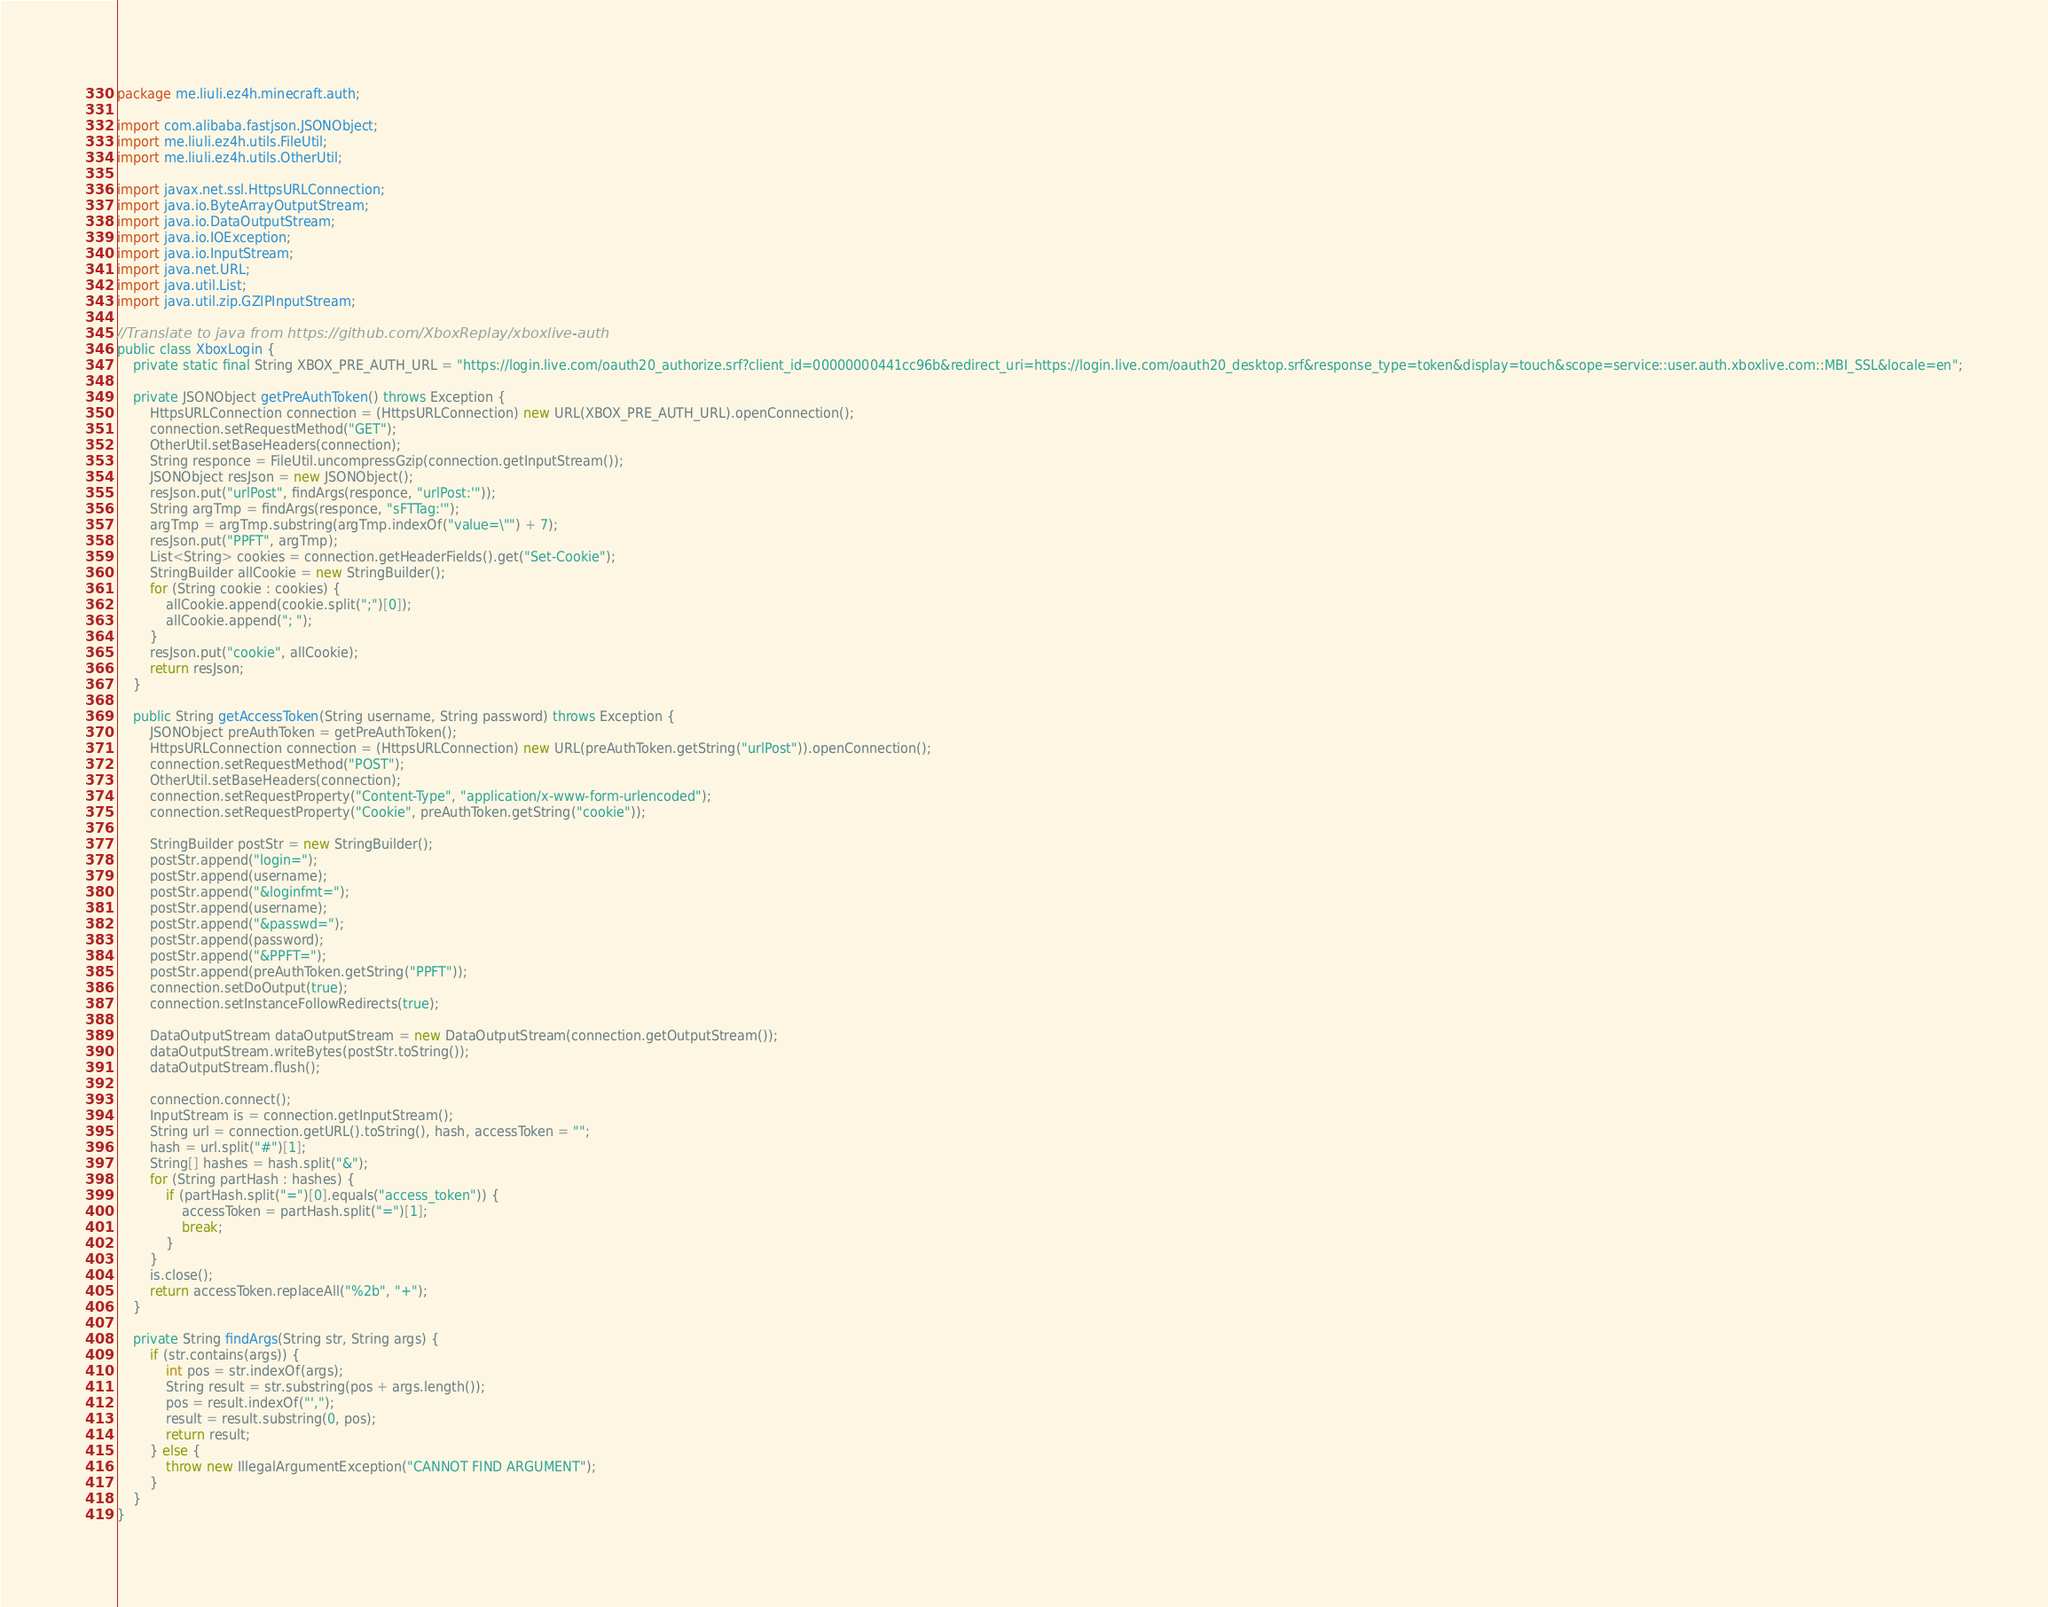<code> <loc_0><loc_0><loc_500><loc_500><_Java_>package me.liuli.ez4h.minecraft.auth;

import com.alibaba.fastjson.JSONObject;
import me.liuli.ez4h.utils.FileUtil;
import me.liuli.ez4h.utils.OtherUtil;

import javax.net.ssl.HttpsURLConnection;
import java.io.ByteArrayOutputStream;
import java.io.DataOutputStream;
import java.io.IOException;
import java.io.InputStream;
import java.net.URL;
import java.util.List;
import java.util.zip.GZIPInputStream;

//Translate to java from https://github.com/XboxReplay/xboxlive-auth
public class XboxLogin {
    private static final String XBOX_PRE_AUTH_URL = "https://login.live.com/oauth20_authorize.srf?client_id=00000000441cc96b&redirect_uri=https://login.live.com/oauth20_desktop.srf&response_type=token&display=touch&scope=service::user.auth.xboxlive.com::MBI_SSL&locale=en";

    private JSONObject getPreAuthToken() throws Exception {
        HttpsURLConnection connection = (HttpsURLConnection) new URL(XBOX_PRE_AUTH_URL).openConnection();
        connection.setRequestMethod("GET");
        OtherUtil.setBaseHeaders(connection);
        String responce = FileUtil.uncompressGzip(connection.getInputStream());
        JSONObject resJson = new JSONObject();
        resJson.put("urlPost", findArgs(responce, "urlPost:'"));
        String argTmp = findArgs(responce, "sFTTag:'");
        argTmp = argTmp.substring(argTmp.indexOf("value=\"") + 7);
        resJson.put("PPFT", argTmp);
        List<String> cookies = connection.getHeaderFields().get("Set-Cookie");
        StringBuilder allCookie = new StringBuilder();
        for (String cookie : cookies) {
            allCookie.append(cookie.split(";")[0]);
            allCookie.append("; ");
        }
        resJson.put("cookie", allCookie);
        return resJson;
    }

    public String getAccessToken(String username, String password) throws Exception {
        JSONObject preAuthToken = getPreAuthToken();
        HttpsURLConnection connection = (HttpsURLConnection) new URL(preAuthToken.getString("urlPost")).openConnection();
        connection.setRequestMethod("POST");
        OtherUtil.setBaseHeaders(connection);
        connection.setRequestProperty("Content-Type", "application/x-www-form-urlencoded");
        connection.setRequestProperty("Cookie", preAuthToken.getString("cookie"));

        StringBuilder postStr = new StringBuilder();
        postStr.append("login=");
        postStr.append(username);
        postStr.append("&loginfmt=");
        postStr.append(username);
        postStr.append("&passwd=");
        postStr.append(password);
        postStr.append("&PPFT=");
        postStr.append(preAuthToken.getString("PPFT"));
        connection.setDoOutput(true);
        connection.setInstanceFollowRedirects(true);

        DataOutputStream dataOutputStream = new DataOutputStream(connection.getOutputStream());
        dataOutputStream.writeBytes(postStr.toString());
        dataOutputStream.flush();

        connection.connect();
        InputStream is = connection.getInputStream();
        String url = connection.getURL().toString(), hash, accessToken = "";
        hash = url.split("#")[1];
        String[] hashes = hash.split("&");
        for (String partHash : hashes) {
            if (partHash.split("=")[0].equals("access_token")) {
                accessToken = partHash.split("=")[1];
                break;
            }
        }
        is.close();
        return accessToken.replaceAll("%2b", "+");
    }

    private String findArgs(String str, String args) {
        if (str.contains(args)) {
            int pos = str.indexOf(args);
            String result = str.substring(pos + args.length());
            pos = result.indexOf("',");
            result = result.substring(0, pos);
            return result;
        } else {
            throw new IllegalArgumentException("CANNOT FIND ARGUMENT");
        }
    }
}
</code> 